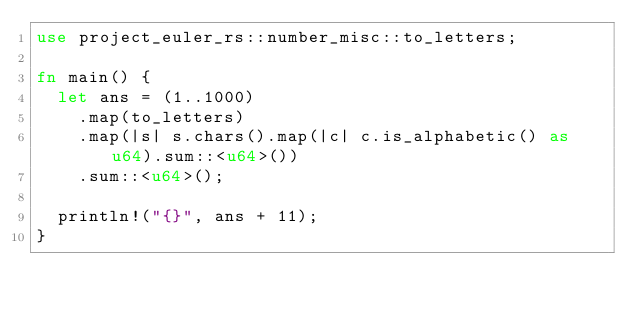<code> <loc_0><loc_0><loc_500><loc_500><_Rust_>use project_euler_rs::number_misc::to_letters;

fn main() {
	let ans = (1..1000)
		.map(to_letters)
		.map(|s| s.chars().map(|c| c.is_alphabetic() as u64).sum::<u64>())
		.sum::<u64>();

	println!("{}", ans + 11);
}
</code> 